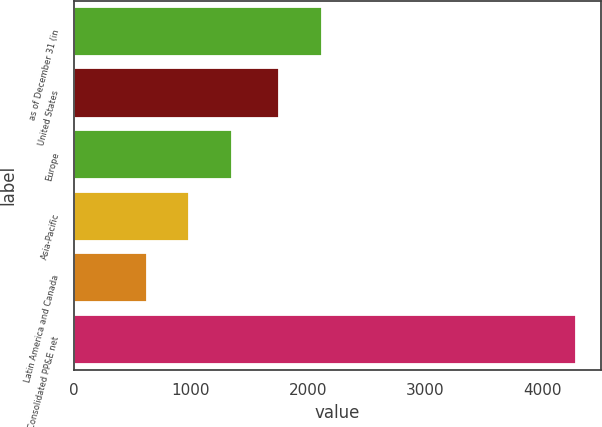Convert chart. <chart><loc_0><loc_0><loc_500><loc_500><bar_chart><fcel>as of December 31 (in<fcel>United States<fcel>Europe<fcel>Asia-Pacific<fcel>Latin America and Canada<fcel>Consolidated PP&E net<nl><fcel>2117.9<fcel>1751<fcel>1353.8<fcel>986.9<fcel>620<fcel>4289<nl></chart> 